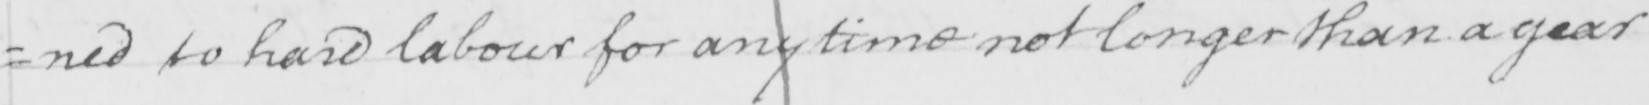What is written in this line of handwriting? =ned to hard labour for any time not longer than a year 